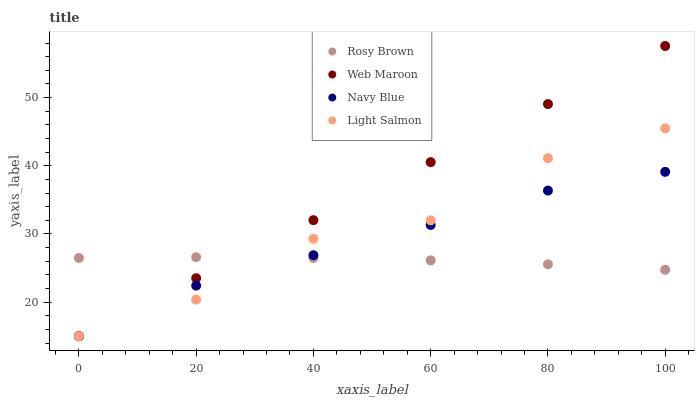Does Rosy Brown have the minimum area under the curve?
Answer yes or no. Yes. Does Web Maroon have the maximum area under the curve?
Answer yes or no. Yes. Does Light Salmon have the minimum area under the curve?
Answer yes or no. No. Does Light Salmon have the maximum area under the curve?
Answer yes or no. No. Is Web Maroon the smoothest?
Answer yes or no. Yes. Is Light Salmon the roughest?
Answer yes or no. Yes. Is Rosy Brown the smoothest?
Answer yes or no. No. Is Rosy Brown the roughest?
Answer yes or no. No. Does Navy Blue have the lowest value?
Answer yes or no. Yes. Does Rosy Brown have the lowest value?
Answer yes or no. No. Does Web Maroon have the highest value?
Answer yes or no. Yes. Does Light Salmon have the highest value?
Answer yes or no. No. Does Navy Blue intersect Light Salmon?
Answer yes or no. Yes. Is Navy Blue less than Light Salmon?
Answer yes or no. No. Is Navy Blue greater than Light Salmon?
Answer yes or no. No. 